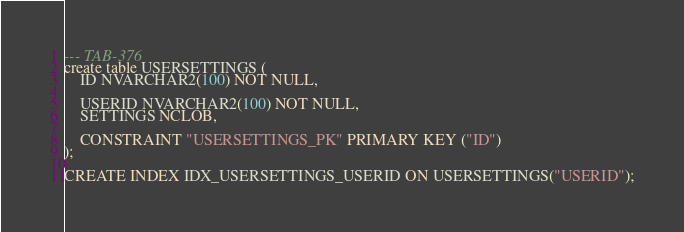Convert code to text. <code><loc_0><loc_0><loc_500><loc_500><_SQL_>--- TAB-376
create table USERSETTINGS (
	ID NVARCHAR2(100) NOT NULL,
	
	USERID NVARCHAR2(100) NOT NULL,
	SETTINGS NCLOB,
	
	CONSTRAINT "USERSETTINGS_PK" PRIMARY KEY ("ID")	
);

CREATE INDEX IDX_USERSETTINGS_USERID ON USERSETTINGS("USERID");</code> 